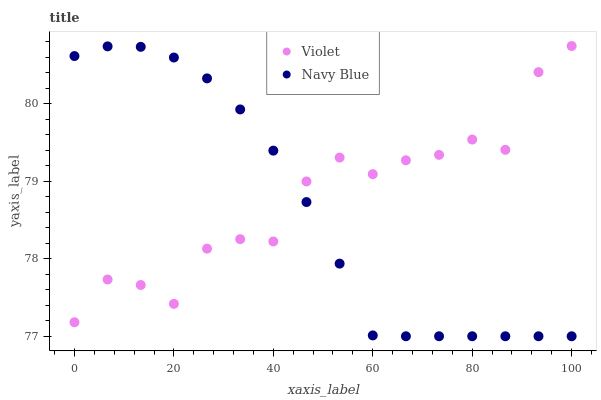Does Navy Blue have the minimum area under the curve?
Answer yes or no. Yes. Does Violet have the maximum area under the curve?
Answer yes or no. Yes. Does Violet have the minimum area under the curve?
Answer yes or no. No. Is Navy Blue the smoothest?
Answer yes or no. Yes. Is Violet the roughest?
Answer yes or no. Yes. Is Violet the smoothest?
Answer yes or no. No. Does Navy Blue have the lowest value?
Answer yes or no. Yes. Does Violet have the lowest value?
Answer yes or no. No. Does Violet have the highest value?
Answer yes or no. Yes. Does Navy Blue intersect Violet?
Answer yes or no. Yes. Is Navy Blue less than Violet?
Answer yes or no. No. Is Navy Blue greater than Violet?
Answer yes or no. No. 